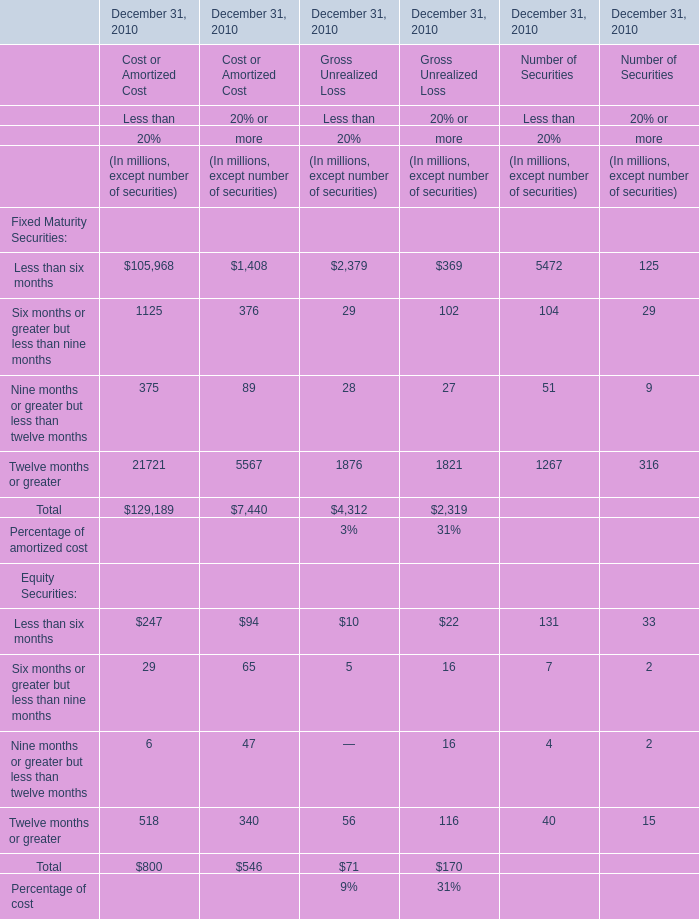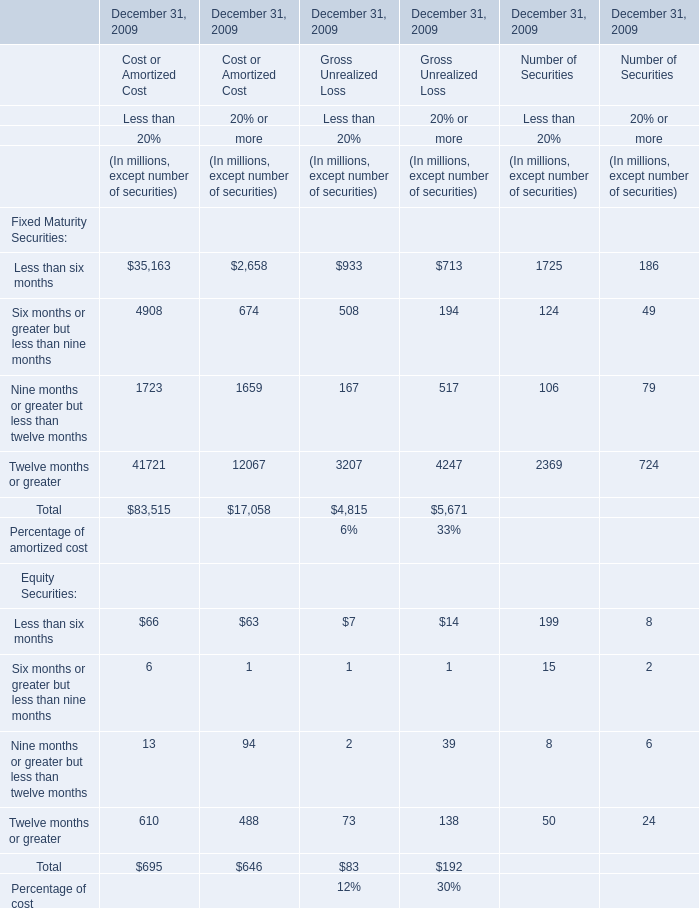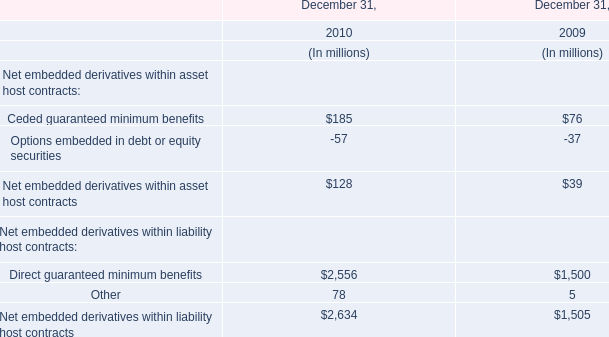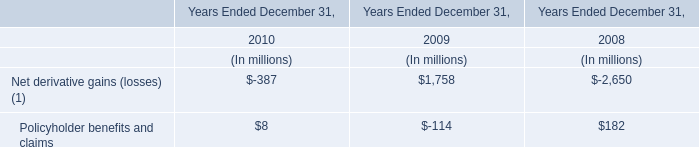Which element for Gross Unrealized Loss of Less than Less than 20% exceeds 10% of total in 2009 ? 
Answer: Less than six months, Six months or greater but less than nine months, Twelve months or greater. 